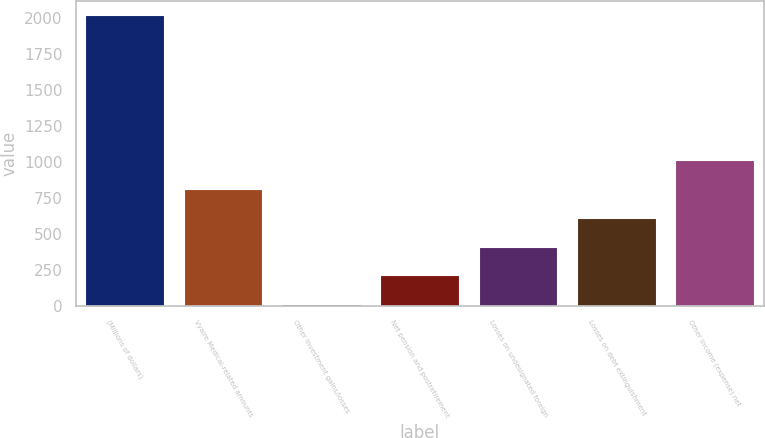Convert chart. <chart><loc_0><loc_0><loc_500><loc_500><bar_chart><fcel>(Millions of dollars)<fcel>Vyaire Medical-related amounts<fcel>Other investment gains/losses<fcel>Net pension and postretirement<fcel>Losses on undesignated foreign<fcel>Losses on debt extinguishment<fcel>Other income (expense) net<nl><fcel>2018<fcel>812<fcel>8<fcel>209<fcel>410<fcel>611<fcel>1013<nl></chart> 